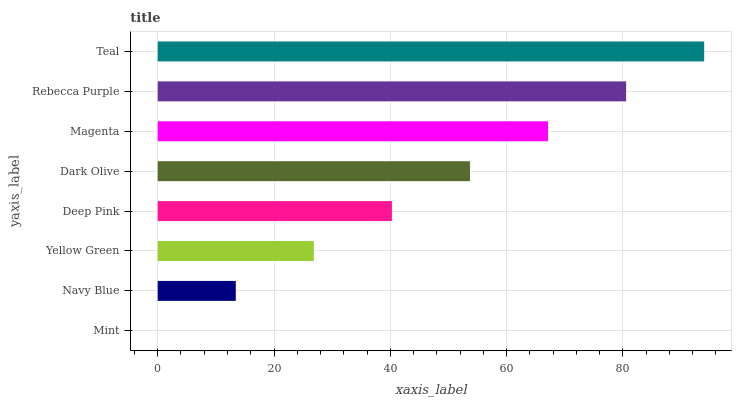Is Mint the minimum?
Answer yes or no. Yes. Is Teal the maximum?
Answer yes or no. Yes. Is Navy Blue the minimum?
Answer yes or no. No. Is Navy Blue the maximum?
Answer yes or no. No. Is Navy Blue greater than Mint?
Answer yes or no. Yes. Is Mint less than Navy Blue?
Answer yes or no. Yes. Is Mint greater than Navy Blue?
Answer yes or no. No. Is Navy Blue less than Mint?
Answer yes or no. No. Is Dark Olive the high median?
Answer yes or no. Yes. Is Deep Pink the low median?
Answer yes or no. Yes. Is Rebecca Purple the high median?
Answer yes or no. No. Is Mint the low median?
Answer yes or no. No. 